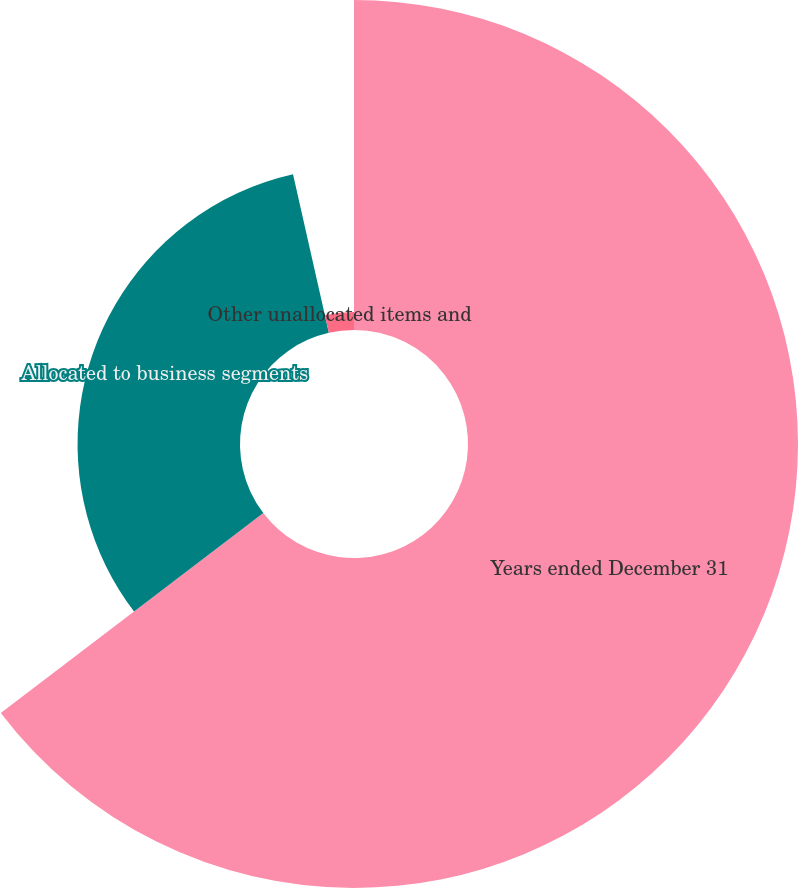Convert chart to OTSL. <chart><loc_0><loc_0><loc_500><loc_500><pie_chart><fcel>Years ended December 31<fcel>Allocated to business segments<fcel>Other unallocated items and<nl><fcel>64.64%<fcel>31.82%<fcel>3.54%<nl></chart> 